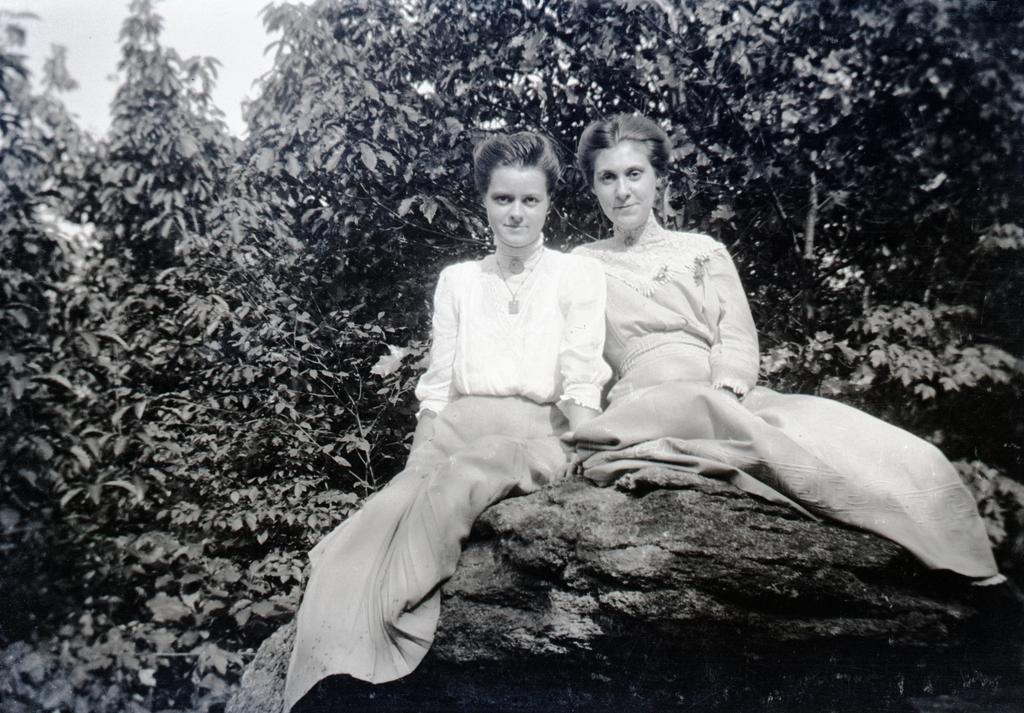Describe this image in one or two sentences. In this black and white picture two women are sitting on the rock. Behind them there are few plants and sky. 